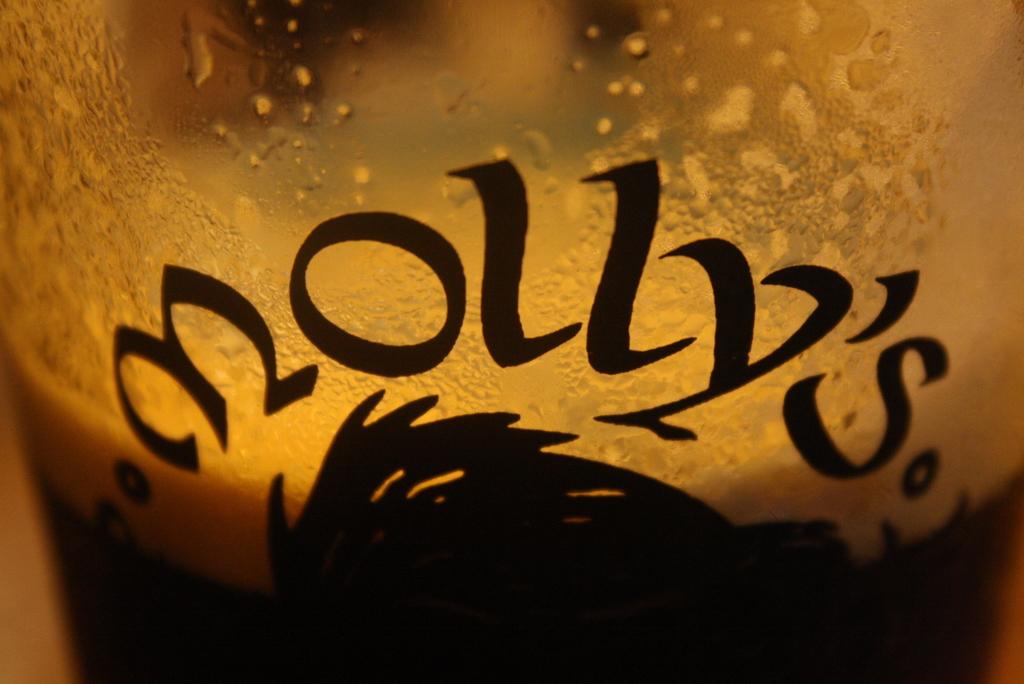What does the glass say?
Give a very brief answer. Molly's. 